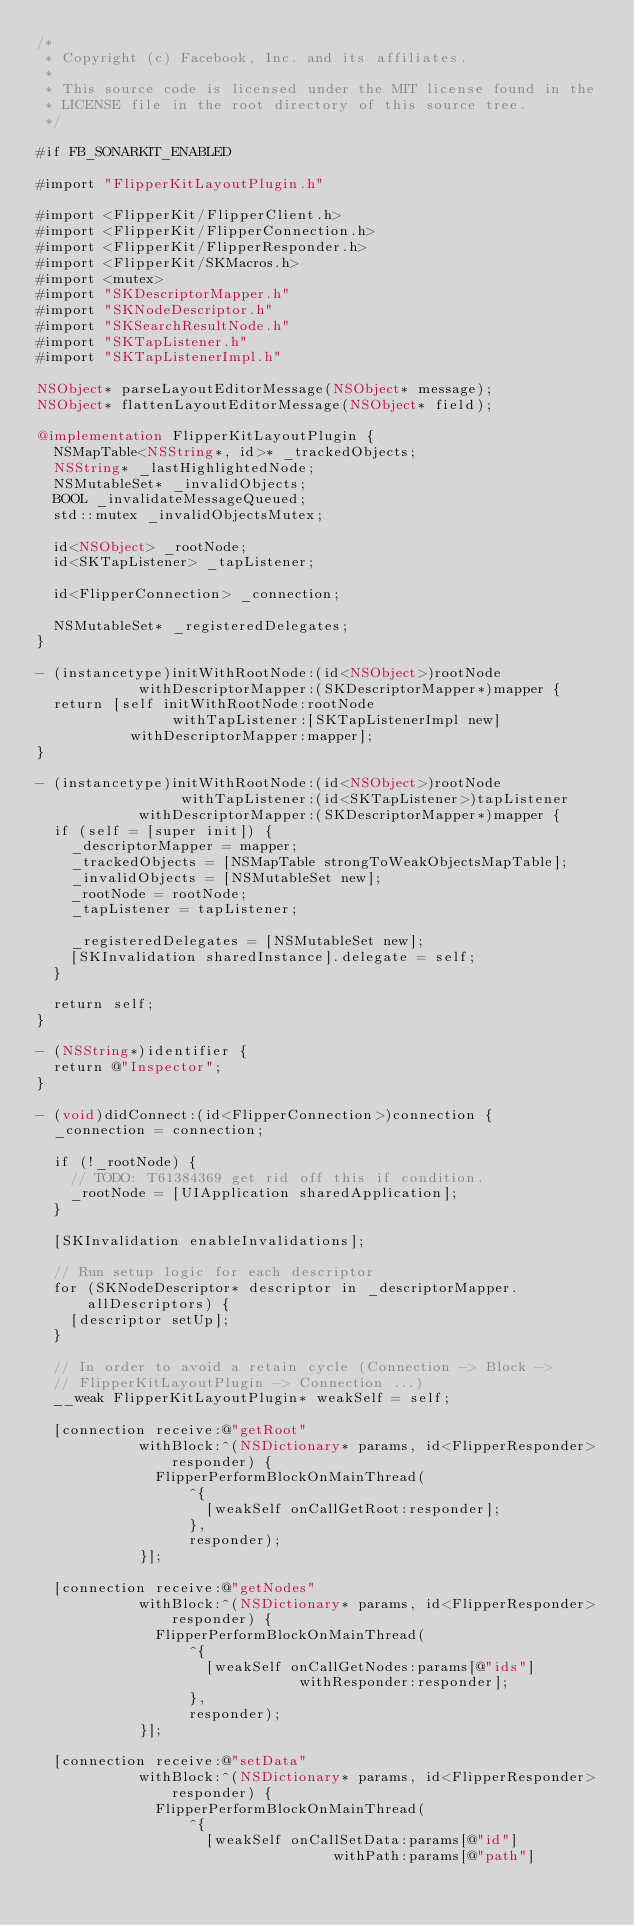Convert code to text. <code><loc_0><loc_0><loc_500><loc_500><_ObjectiveC_>/*
 * Copyright (c) Facebook, Inc. and its affiliates.
 *
 * This source code is licensed under the MIT license found in the
 * LICENSE file in the root directory of this source tree.
 */

#if FB_SONARKIT_ENABLED

#import "FlipperKitLayoutPlugin.h"

#import <FlipperKit/FlipperClient.h>
#import <FlipperKit/FlipperConnection.h>
#import <FlipperKit/FlipperResponder.h>
#import <FlipperKit/SKMacros.h>
#import <mutex>
#import "SKDescriptorMapper.h"
#import "SKNodeDescriptor.h"
#import "SKSearchResultNode.h"
#import "SKTapListener.h"
#import "SKTapListenerImpl.h"

NSObject* parseLayoutEditorMessage(NSObject* message);
NSObject* flattenLayoutEditorMessage(NSObject* field);

@implementation FlipperKitLayoutPlugin {
  NSMapTable<NSString*, id>* _trackedObjects;
  NSString* _lastHighlightedNode;
  NSMutableSet* _invalidObjects;
  BOOL _invalidateMessageQueued;
  std::mutex _invalidObjectsMutex;

  id<NSObject> _rootNode;
  id<SKTapListener> _tapListener;

  id<FlipperConnection> _connection;

  NSMutableSet* _registeredDelegates;
}

- (instancetype)initWithRootNode:(id<NSObject>)rootNode
            withDescriptorMapper:(SKDescriptorMapper*)mapper {
  return [self initWithRootNode:rootNode
                withTapListener:[SKTapListenerImpl new]
           withDescriptorMapper:mapper];
}

- (instancetype)initWithRootNode:(id<NSObject>)rootNode
                 withTapListener:(id<SKTapListener>)tapListener
            withDescriptorMapper:(SKDescriptorMapper*)mapper {
  if (self = [super init]) {
    _descriptorMapper = mapper;
    _trackedObjects = [NSMapTable strongToWeakObjectsMapTable];
    _invalidObjects = [NSMutableSet new];
    _rootNode = rootNode;
    _tapListener = tapListener;

    _registeredDelegates = [NSMutableSet new];
    [SKInvalidation sharedInstance].delegate = self;
  }

  return self;
}

- (NSString*)identifier {
  return @"Inspector";
}

- (void)didConnect:(id<FlipperConnection>)connection {
  _connection = connection;

  if (!_rootNode) {
    // TODO: T61384369 get rid off this if condition.
    _rootNode = [UIApplication sharedApplication];
  }

  [SKInvalidation enableInvalidations];

  // Run setup logic for each descriptor
  for (SKNodeDescriptor* descriptor in _descriptorMapper.allDescriptors) {
    [descriptor setUp];
  }

  // In order to avoid a retain cycle (Connection -> Block ->
  // FlipperKitLayoutPlugin -> Connection ...)
  __weak FlipperKitLayoutPlugin* weakSelf = self;

  [connection receive:@"getRoot"
            withBlock:^(NSDictionary* params, id<FlipperResponder> responder) {
              FlipperPerformBlockOnMainThread(
                  ^{
                    [weakSelf onCallGetRoot:responder];
                  },
                  responder);
            }];

  [connection receive:@"getNodes"
            withBlock:^(NSDictionary* params, id<FlipperResponder> responder) {
              FlipperPerformBlockOnMainThread(
                  ^{
                    [weakSelf onCallGetNodes:params[@"ids"]
                               withResponder:responder];
                  },
                  responder);
            }];

  [connection receive:@"setData"
            withBlock:^(NSDictionary* params, id<FlipperResponder> responder) {
              FlipperPerformBlockOnMainThread(
                  ^{
                    [weakSelf onCallSetData:params[@"id"]
                                   withPath:params[@"path"]</code> 